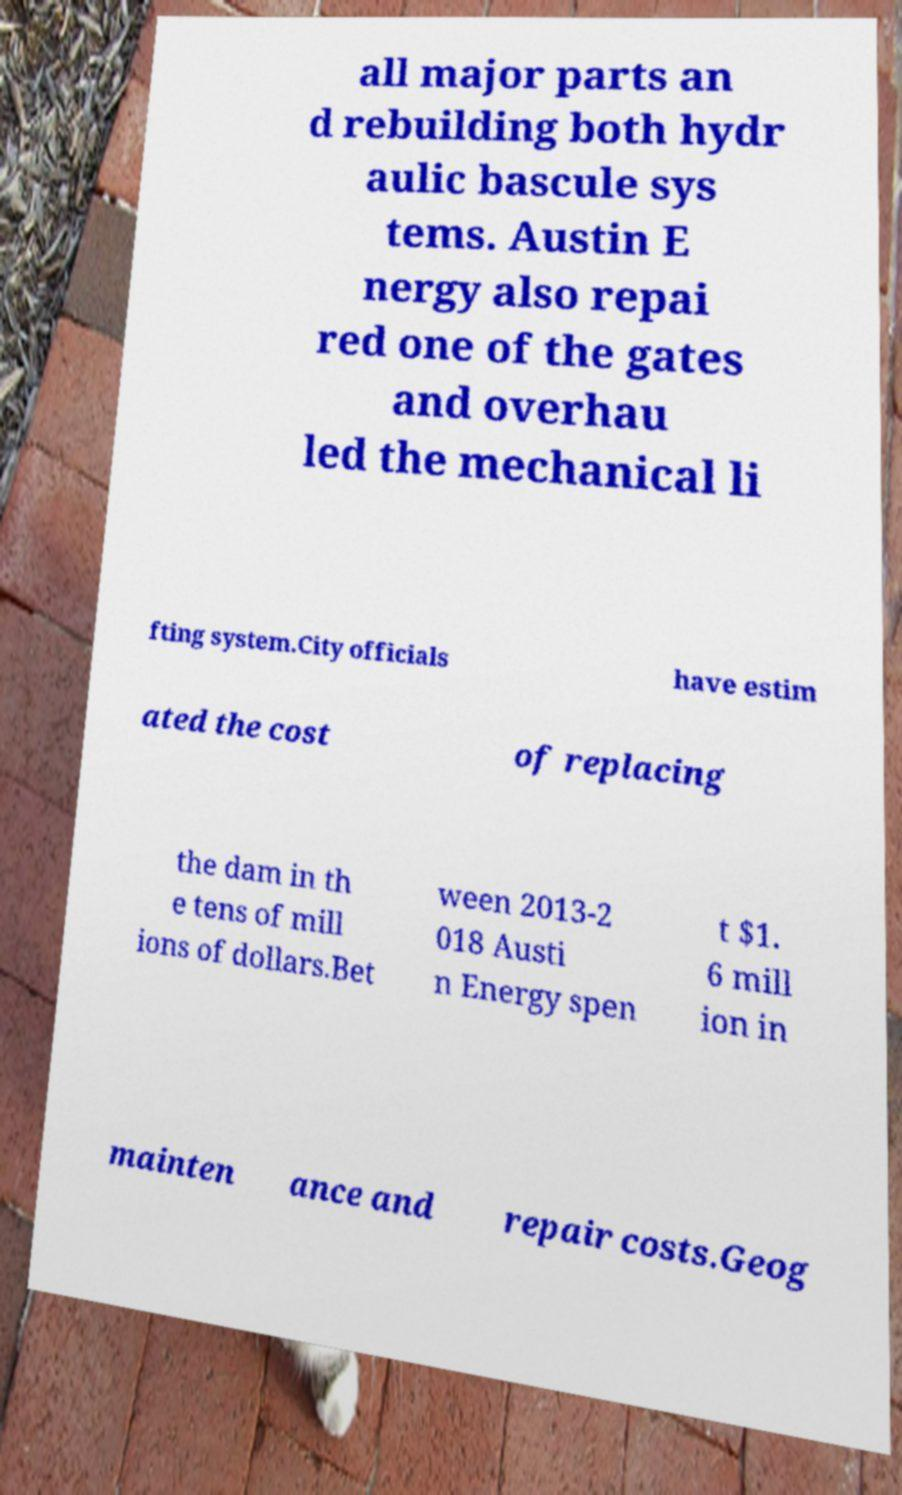Could you extract and type out the text from this image? all major parts an d rebuilding both hydr aulic bascule sys tems. Austin E nergy also repai red one of the gates and overhau led the mechanical li fting system.City officials have estim ated the cost of replacing the dam in th e tens of mill ions of dollars.Bet ween 2013-2 018 Austi n Energy spen t $1. 6 mill ion in mainten ance and repair costs.Geog 